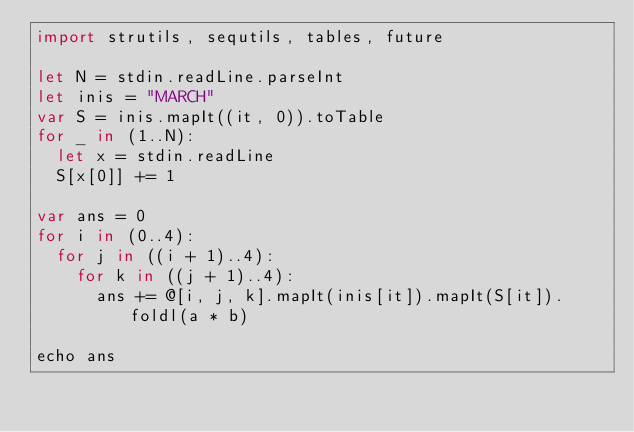<code> <loc_0><loc_0><loc_500><loc_500><_Nim_>import strutils, sequtils, tables, future

let N = stdin.readLine.parseInt
let inis = "MARCH"
var S = inis.mapIt((it, 0)).toTable
for _ in (1..N):
  let x = stdin.readLine
  S[x[0]] += 1

var ans = 0
for i in (0..4):
  for j in ((i + 1)..4):
    for k in ((j + 1)..4):
      ans += @[i, j, k].mapIt(inis[it]).mapIt(S[it]).foldl(a * b)

echo ans
</code> 